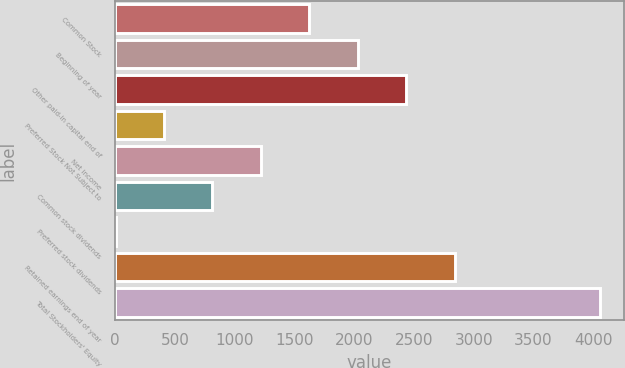<chart> <loc_0><loc_0><loc_500><loc_500><bar_chart><fcel>Common Stock<fcel>Beginning of year<fcel>Other paid-in capital end of<fcel>Preferred Stock Not Subject to<fcel>Net income<fcel>Common stock dividends<fcel>Preferred stock dividends<fcel>Retained earnings end of year<fcel>Total Stockholders' Equity<nl><fcel>1623.4<fcel>2028.5<fcel>2433.6<fcel>408.1<fcel>1218.3<fcel>813.2<fcel>3<fcel>2838.7<fcel>4054<nl></chart> 